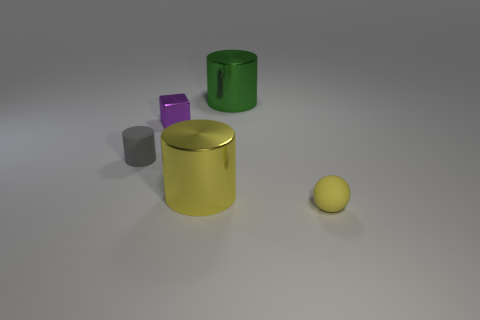Is there another small sphere that has the same color as the tiny ball?
Your answer should be compact. No. There is a tiny rubber thing that is on the left side of the large green cylinder; does it have the same shape as the small yellow rubber thing that is in front of the tiny gray thing?
Your response must be concise. No. Are there any small cyan blocks that have the same material as the green cylinder?
Ensure brevity in your answer.  No. How many gray objects are either cylinders or large objects?
Make the answer very short. 1. There is a cylinder that is right of the block and in front of the green metallic thing; what size is it?
Offer a very short reply. Large. Is the number of tiny objects that are in front of the purple metallic cube greater than the number of small yellow metal cylinders?
Keep it short and to the point. Yes. How many spheres are either cyan objects or tiny purple metal things?
Ensure brevity in your answer.  0. What is the shape of the small thing that is on the right side of the gray thing and in front of the metal block?
Offer a terse response. Sphere. Is the number of small things that are left of the matte cylinder the same as the number of yellow matte spheres that are behind the yellow sphere?
Provide a short and direct response. Yes. How many objects are small blue things or matte objects?
Your response must be concise. 2. 